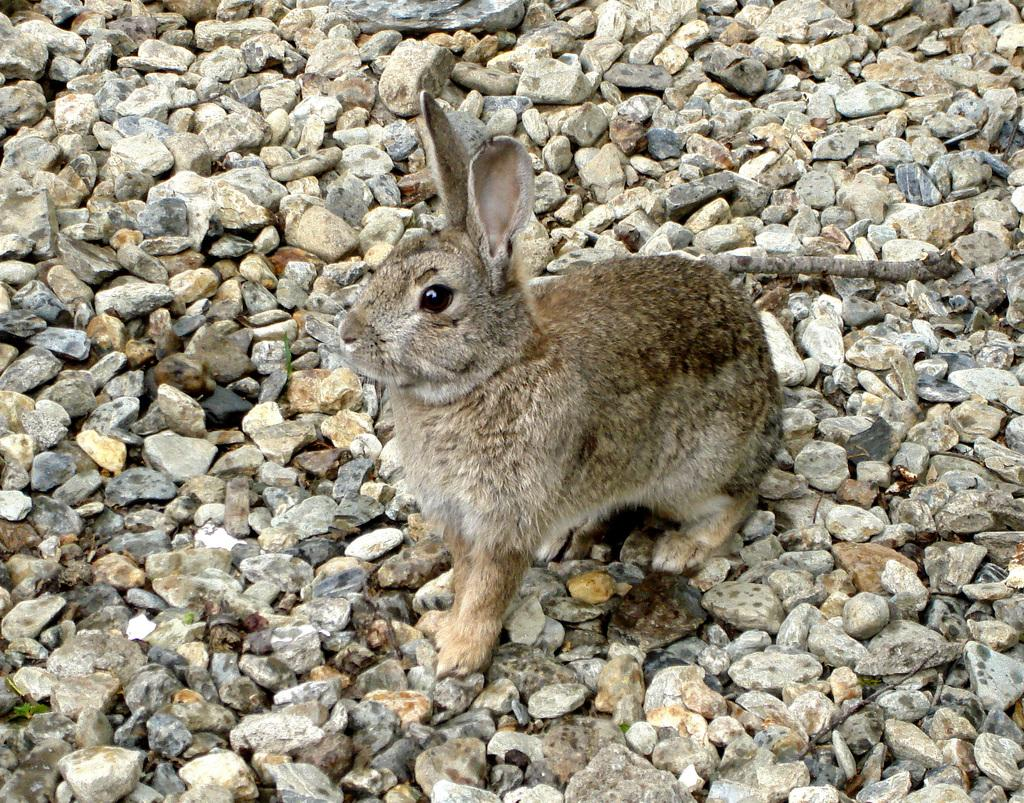What animal is present in the image? There is a rabbit in the image. What is the rabbit sitting on? The rabbit is sitting on stones. What is the color of the rabbit? The rabbit is brown in color. What type of card is the rabbit holding in the image? There is no card present in the image; the rabbit is sitting on stones and is brown in color. 